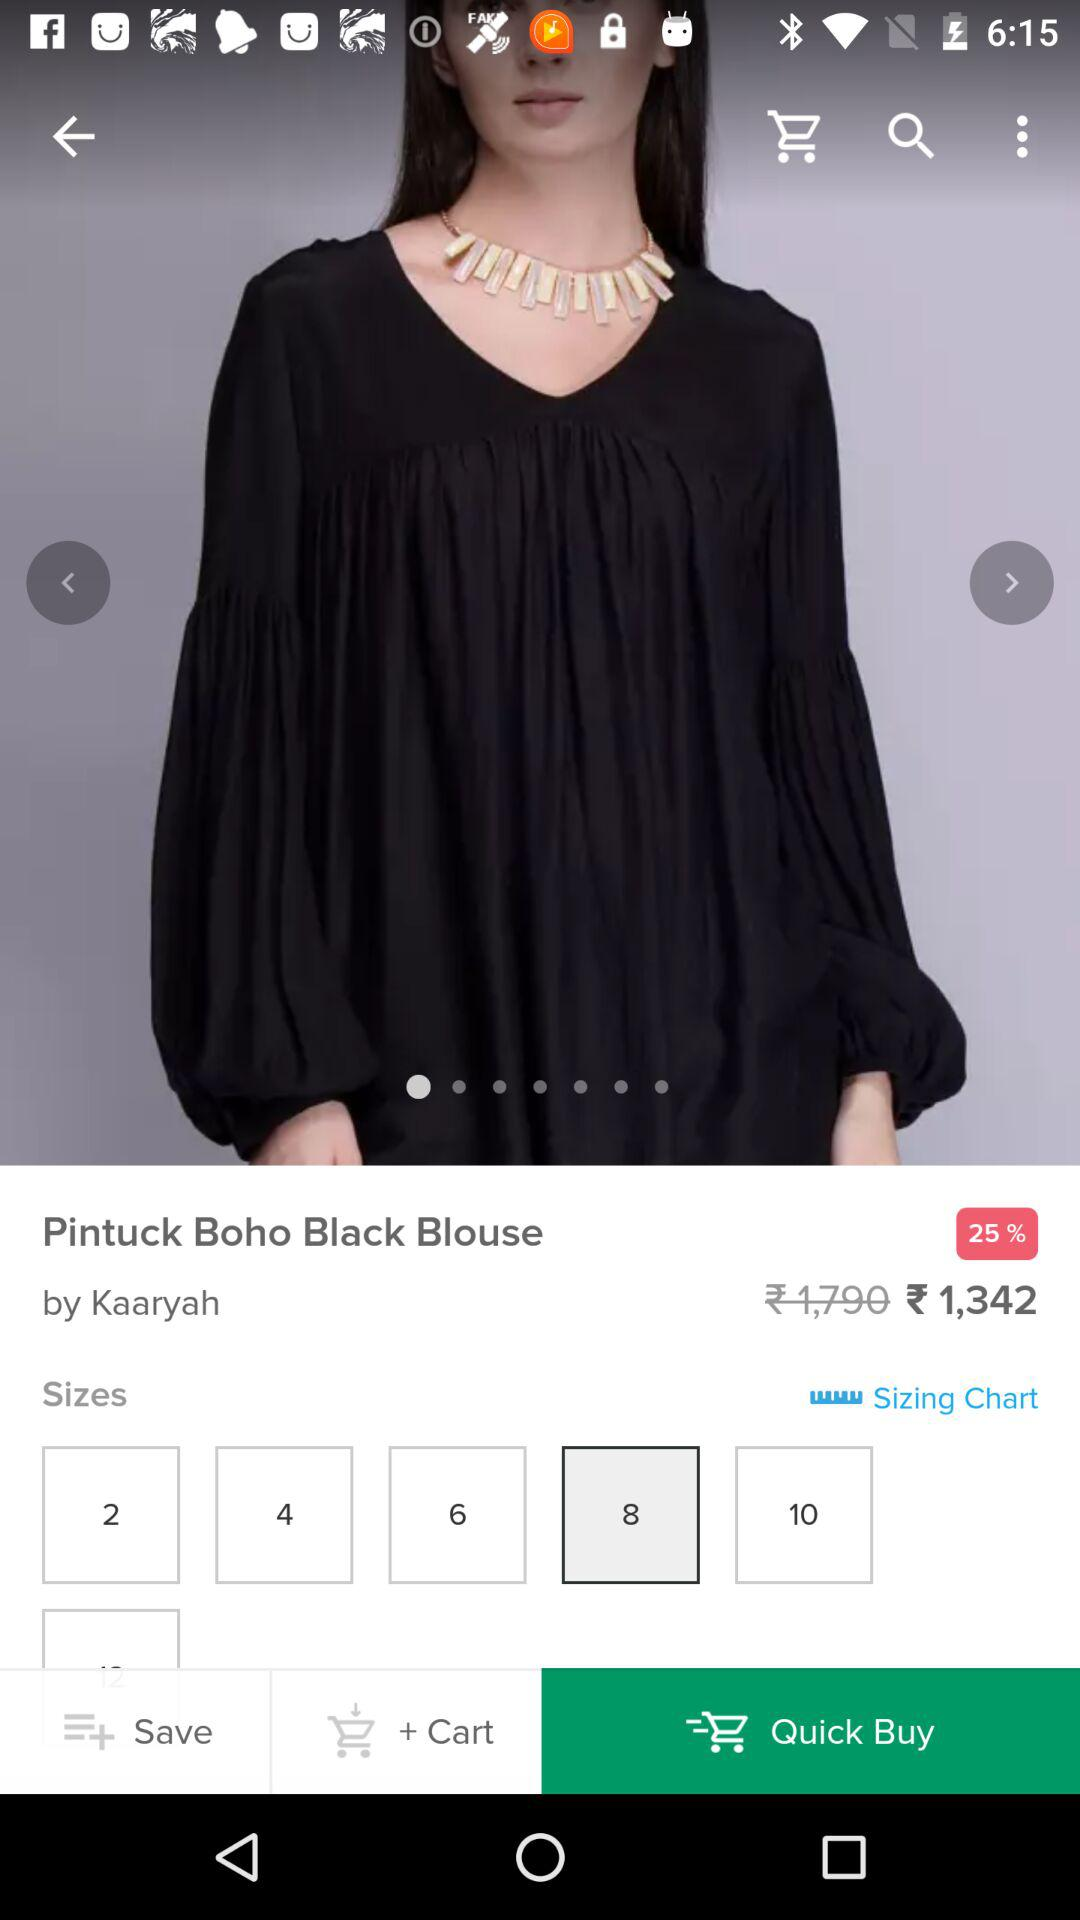What are the available sizes? The available sizes are 2, 4, 6, 8 and 10. 